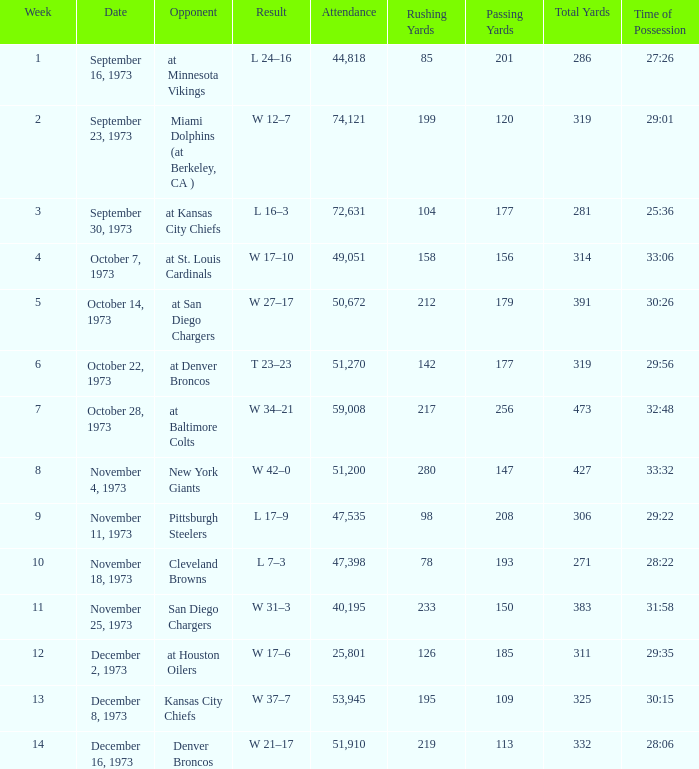What is the attendance for the game against the Kansas City Chiefs earlier than week 13? None. 